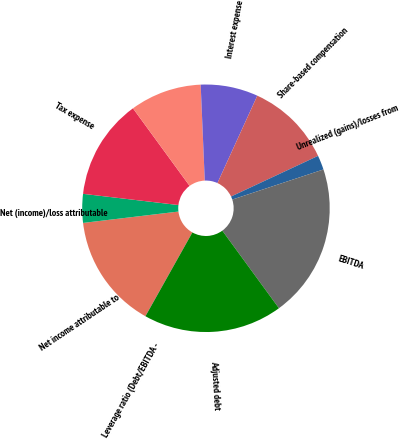Convert chart. <chart><loc_0><loc_0><loc_500><loc_500><pie_chart><fcel>Net income attributable to<fcel>Net (income)/loss attributable<fcel>Tax expense<fcel>Unnamed: 3<fcel>Interest expense<fcel>Share-based compensation<fcel>Unrealized (gains)/losses from<fcel>EBITDA<fcel>Adjusted debt<fcel>Leverage ratio (Debt/EBITDA -<nl><fcel>14.97%<fcel>3.75%<fcel>13.1%<fcel>9.36%<fcel>7.49%<fcel>11.23%<fcel>1.88%<fcel>20.04%<fcel>18.17%<fcel>0.01%<nl></chart> 